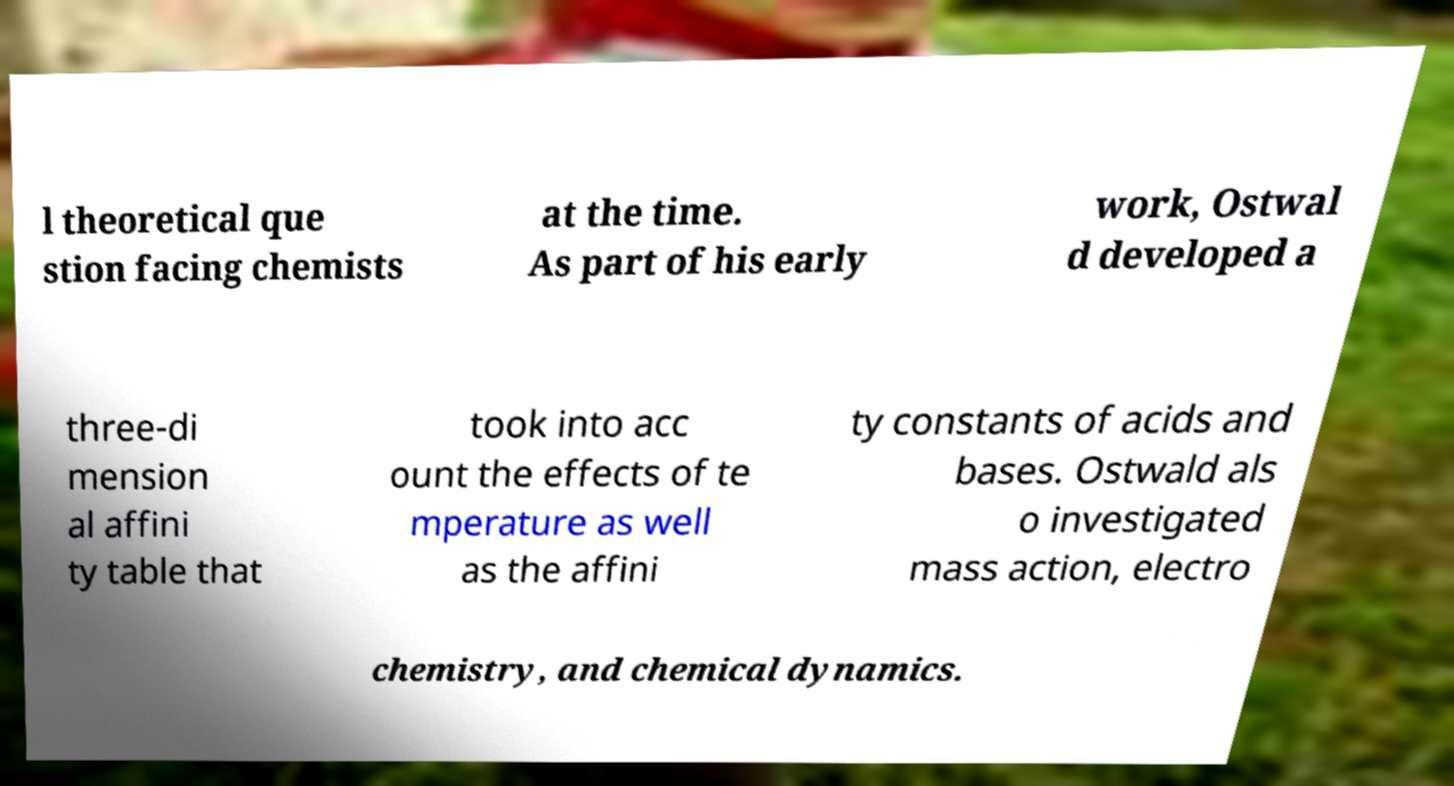For documentation purposes, I need the text within this image transcribed. Could you provide that? l theoretical que stion facing chemists at the time. As part of his early work, Ostwal d developed a three-di mension al affini ty table that took into acc ount the effects of te mperature as well as the affini ty constants of acids and bases. Ostwald als o investigated mass action, electro chemistry, and chemical dynamics. 